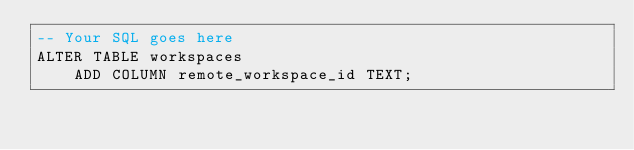<code> <loc_0><loc_0><loc_500><loc_500><_SQL_>-- Your SQL goes here
ALTER TABLE workspaces
    ADD COLUMN remote_workspace_id TEXT;
</code> 